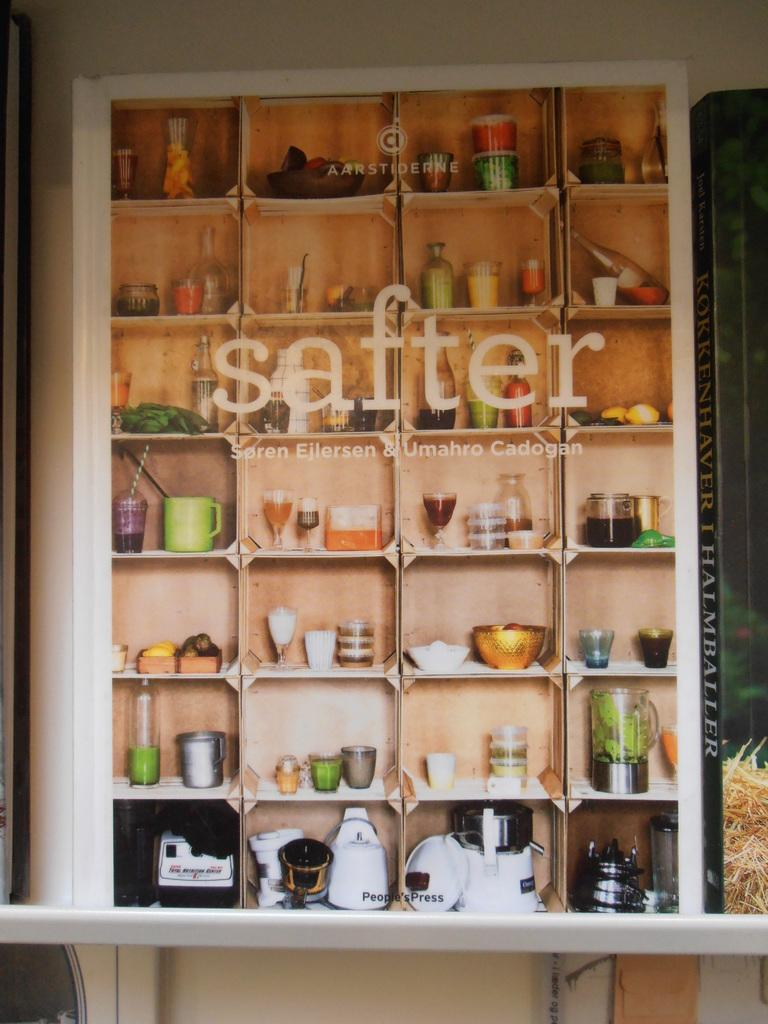<image>
Render a clear and concise summary of the photo. Varius small objects are on display in a cabinet with Safter and other workds etched on the glass. 